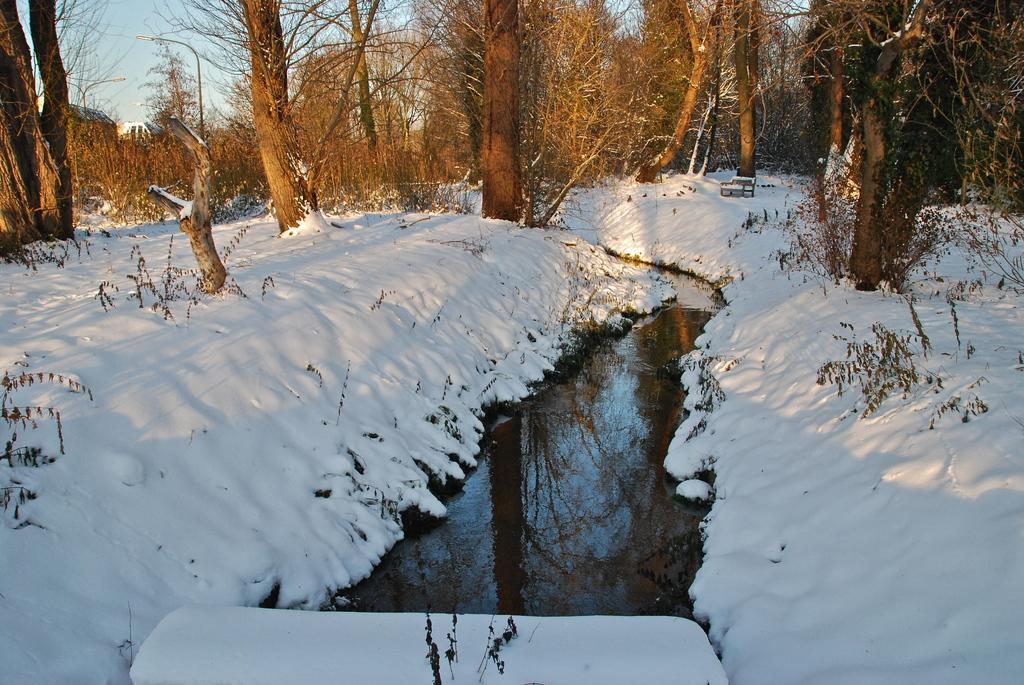How would you summarize this image in a sentence or two? In this image, we can see snow, water, plants and trees. In the background, we can see the streetlights and sky. 